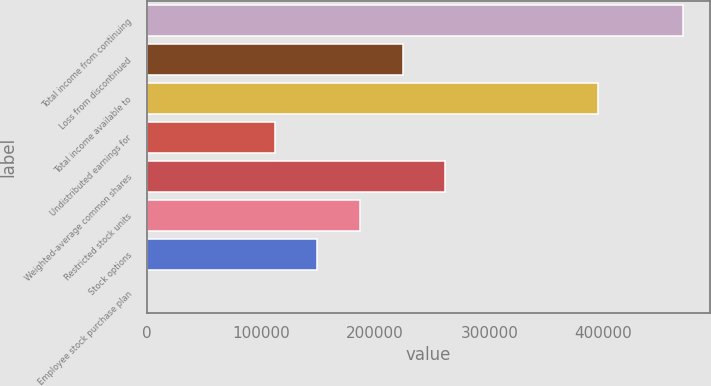Convert chart. <chart><loc_0><loc_0><loc_500><loc_500><bar_chart><fcel>Total income from continuing<fcel>Loss from discontinued<fcel>Total income available to<fcel>Undistributed earnings for<fcel>Weighted-average common shares<fcel>Restricted stock units<fcel>Stock options<fcel>Employee stock purchase plan<nl><fcel>469980<fcel>224110<fcel>395278<fcel>112056<fcel>261462<fcel>186758<fcel>149407<fcel>1<nl></chart> 